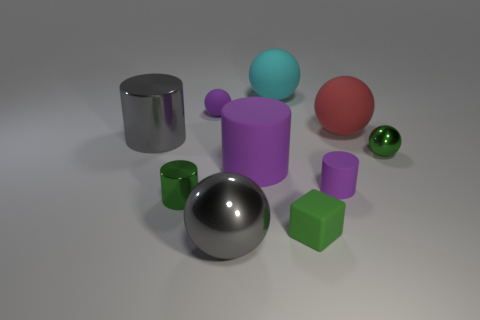Subtract all gray blocks. How many purple cylinders are left? 2 Subtract all large gray balls. How many balls are left? 4 Subtract all green cylinders. How many cylinders are left? 3 Subtract 1 cylinders. How many cylinders are left? 3 Subtract all cylinders. How many objects are left? 6 Subtract all small things. Subtract all rubber spheres. How many objects are left? 2 Add 9 large purple cylinders. How many large purple cylinders are left? 10 Add 8 gray cylinders. How many gray cylinders exist? 9 Subtract 0 cyan cylinders. How many objects are left? 10 Subtract all purple balls. Subtract all brown cylinders. How many balls are left? 4 